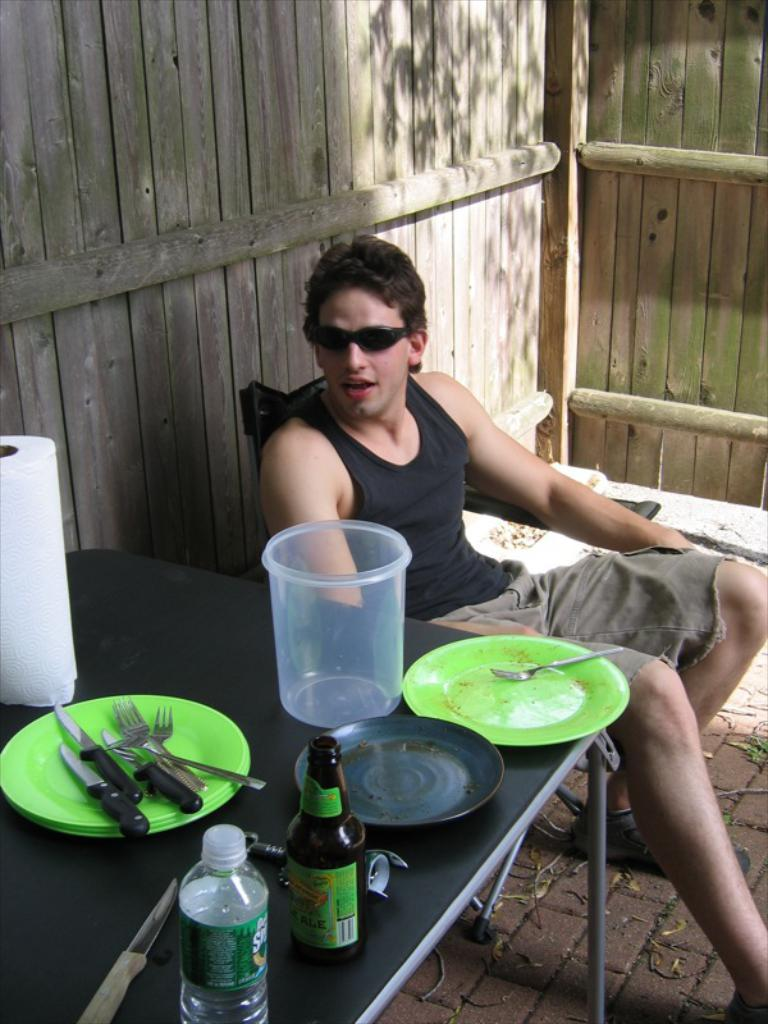What is the man in the image doing? The man is sitting on a chair in the image. What objects can be seen on the table in the image? There is a bottle, a knife, forks, plates, a tissue roll, and a plastic vessel on the table in the image. What type of table is present in the image? There is a table in the image. What type of popcorn is being served in space in the image? There is no popcorn or space depicted in the image; it features a man sitting on a chair and objects on a table. What type of alarm is present in the image? There is no alarm present in the image. 